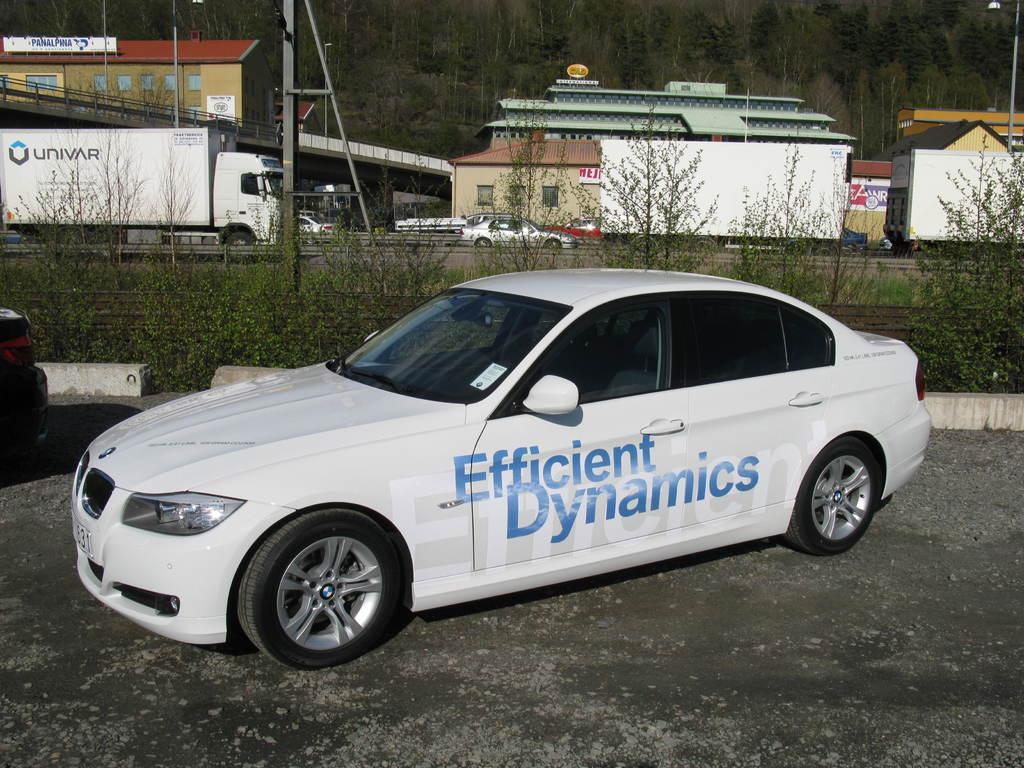Please provide a concise description of this image. In this image there is a white color car in the bottom of this image and there are some trees in the background. There are some houses on the top of this image and there is a vehicle on the left side of this image and there are some trees on the top of this image. 